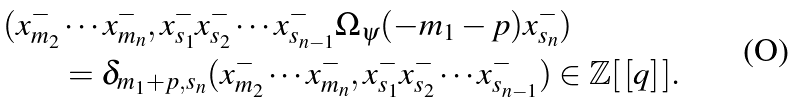Convert formula to latex. <formula><loc_0><loc_0><loc_500><loc_500>( x ^ { - } _ { m _ { 2 } } & \cdots x ^ { - } _ { m _ { n } } , x ^ { - } _ { s _ { 1 } } x ^ { - } _ { s _ { 2 } } \cdots x ^ { - } _ { s _ { n - 1 } } \Omega _ { \psi } ( - m _ { 1 } - p ) x _ { s _ { n } } ^ { - } ) \\ & = \delta _ { m _ { 1 } + p , s _ { n } } ( x ^ { - } _ { m _ { 2 } } \cdots x ^ { - } _ { m _ { n } } , x ^ { - } _ { s _ { 1 } } x ^ { - } _ { s _ { 2 } } \cdots x ^ { - } _ { s _ { n - 1 } } ) \in \mathbb { Z } [ \, [ q ] \, ] .</formula> 